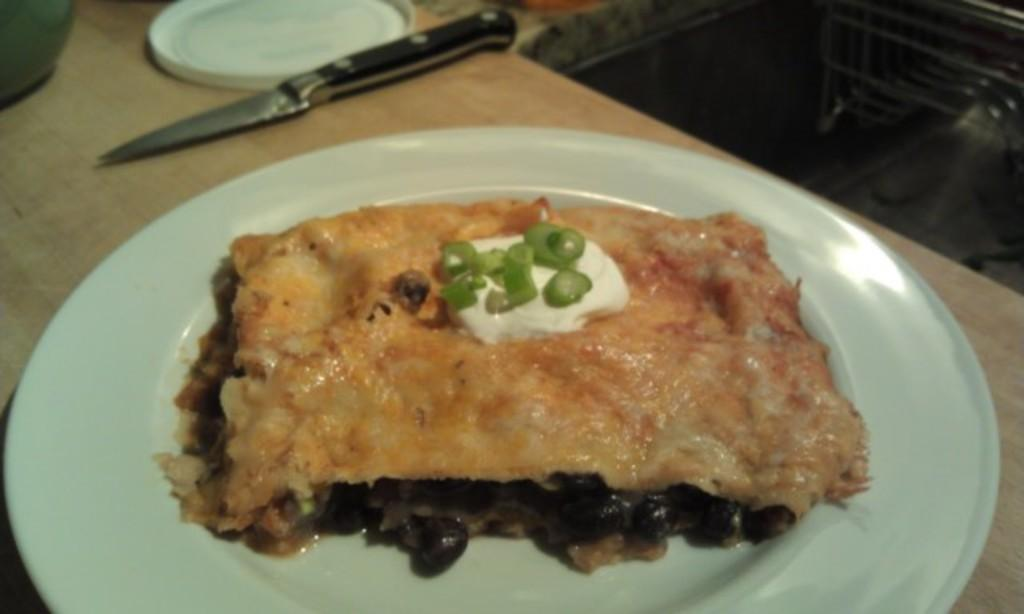What type of surface is visible in the image? There is a wooden surface in the image. What is on the wooden surface? There is a plate with a food item on the wooden surface, as well as a knife and other unspecified items. What time does the clock on the wooden surface display in the image? There is no clock present on the wooden surface in the image. What type of cheese is visible on the wooden surface in the image? There is no cheese visible on the wooden surface in the image. 